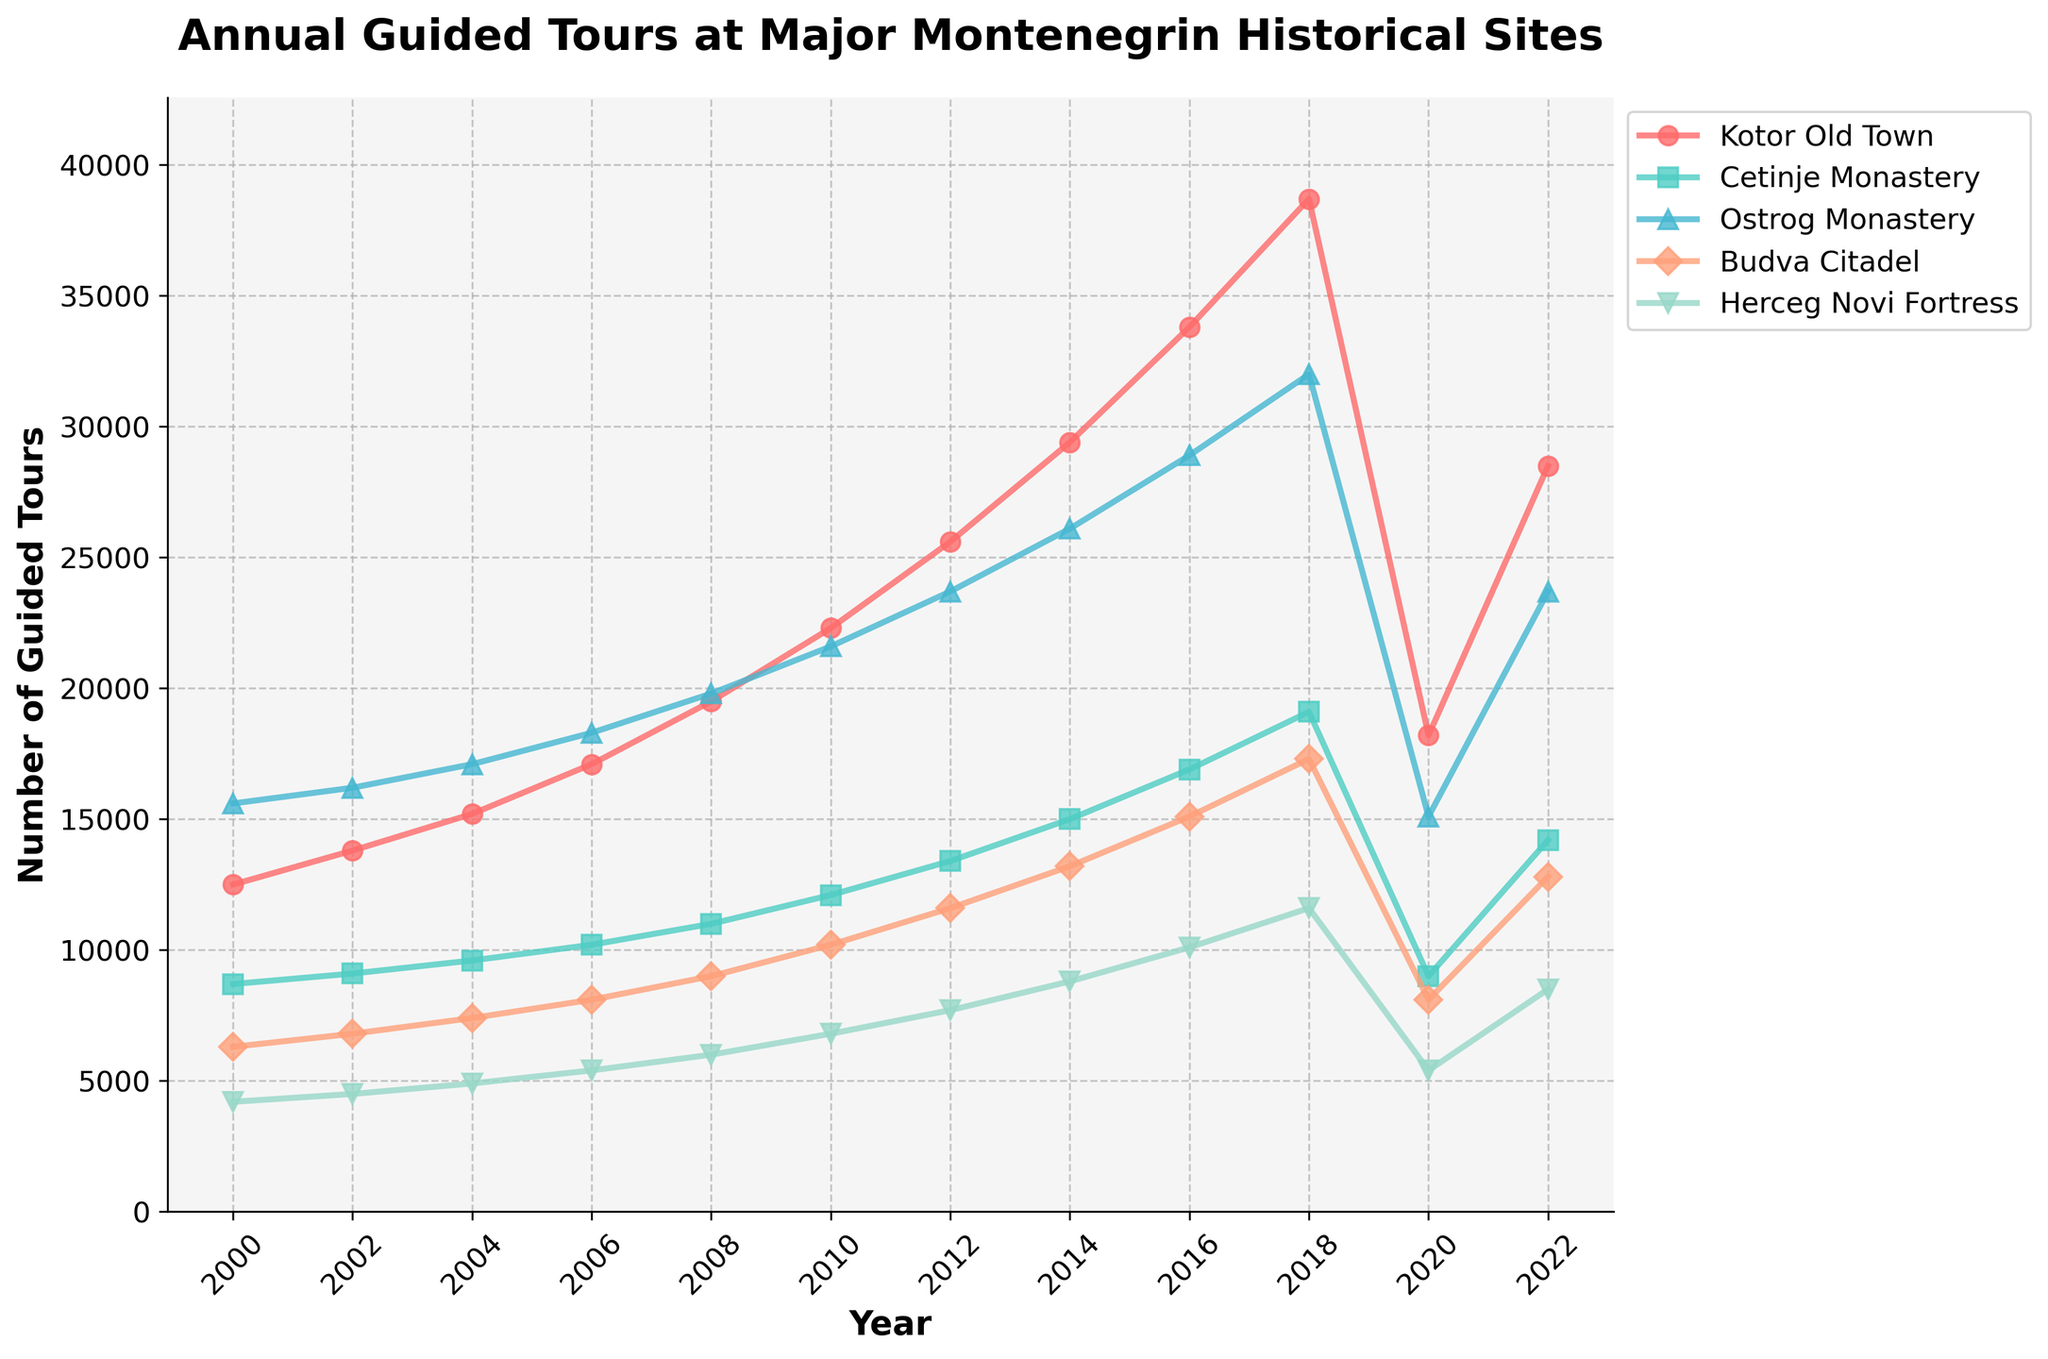Which site had the highest number of guided tours in 2018? Identify the data point for each site in the year 2018 and compare their values. Ostrog Monastery had 32,000 guided tours, which is the highest among the listed sites in 2018.
Answer: Ostrog Monastery What was the percentage decrease in the number of guided tours at Kotor Old Town from 2018 to 2020? Find the number of guided tours at Kotor Old Town in 2018 (38,700) and in 2020 (18,200). Calculate the difference (38,700 - 18,200 = 20,500), then divide the difference by the 2018 value and multiply by 100 for the percentage decrease. (20,500 / 38,700) * 100 ≈ 53%.
Answer: 53% How many more guided tours were conducted at Cetinje Monastery than at Herceg Novi Fortress in 2022? Find the number of guided tours at Cetinje Monastery in 2022 (14,200) and at Herceg Novi Fortress in 2022 (8,500). Subtract the number of guided tours at Herceg Novi Fortress from the number at Cetinje Monastery (14,200 - 8,500 = 5,700).
Answer: 5,700 In which year did Budva Citadel first exceed 15,000 annual guided tours? Find the year in the data for Budva Citadel where the number of guided tours first exceeds 15,000. In 2016, Budva Citadel had 15,100 guided tours.
Answer: 2016 What was the lowest number of guided tours conducted at any of the sites in 2010? Compare the number of guided tours for all sites in 2010. Herceg Novi Fortress had the lowest number at 6,800.
Answer: 6,800 Which site showed the most consistent increase in guided tours from 2000 to 2018? Evaluate the trend for each site from 2000 to 2018 and identify which site had the most steady and uninterrupted increase. Kotor Old Town showed the most consistent increase from 12,500 in 2000 to 38,700 in 2018.
Answer: Kotor Old Town What is the average number of guided tours conducted at Ostrog Monastery over the years available in the data? Sum the number of guided tours at Ostrog Monastery across all years (15600 + 16200 + 17100 + 18300 + 19800 + 21600 + 23700 + 26100 + 28900 + 32000 + 15100 + 23700) and divide by the number of years (12). (238700 / 12 ≈ 19,892).
Answer: 19,892 Between 2010 and 2020, which site experienced the largest absolute decline in the number of guided tours? Calculate the decline for each site between 2010 and 2020 by subtracting the 2020 value from the 2010 value. Ostrog Monastery had the largest decline from 21,600 to 15,100, a decrease of 6,500.
Answer: Ostrog Monastery What was the combined number of guided tours for all sites in 2008? Sum the number of guided tours for all sites in 2008 (19500 + 11000 + 19800 + 9000 + 6000) = 65300.
Answer: 65,300 How many guided tours were conducted at Cetinje Monastery in 2014, and what was its growth rate from 2012? Find the number of guided tours at Cetinje Monastery in 2014 (15,000) and 2012 (13,400). Calculate the growth by subtracting 2012 value from 2014 value (15,000 - 13,400 = 1,600), then divide by the 2012 value and multiply by 100 for the percentage growth ((1,600 / 13,400) * 100) ≈ 11.9%.
Answer: 11.9% 